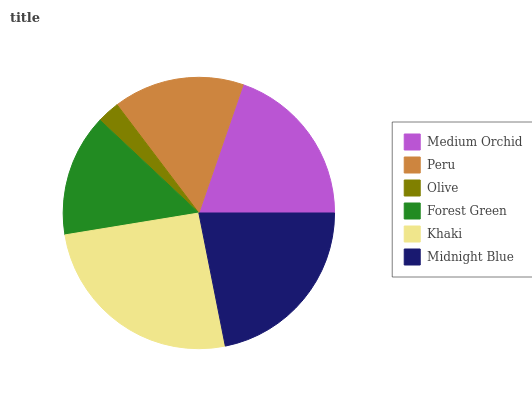Is Olive the minimum?
Answer yes or no. Yes. Is Khaki the maximum?
Answer yes or no. Yes. Is Peru the minimum?
Answer yes or no. No. Is Peru the maximum?
Answer yes or no. No. Is Medium Orchid greater than Peru?
Answer yes or no. Yes. Is Peru less than Medium Orchid?
Answer yes or no. Yes. Is Peru greater than Medium Orchid?
Answer yes or no. No. Is Medium Orchid less than Peru?
Answer yes or no. No. Is Medium Orchid the high median?
Answer yes or no. Yes. Is Peru the low median?
Answer yes or no. Yes. Is Forest Green the high median?
Answer yes or no. No. Is Olive the low median?
Answer yes or no. No. 